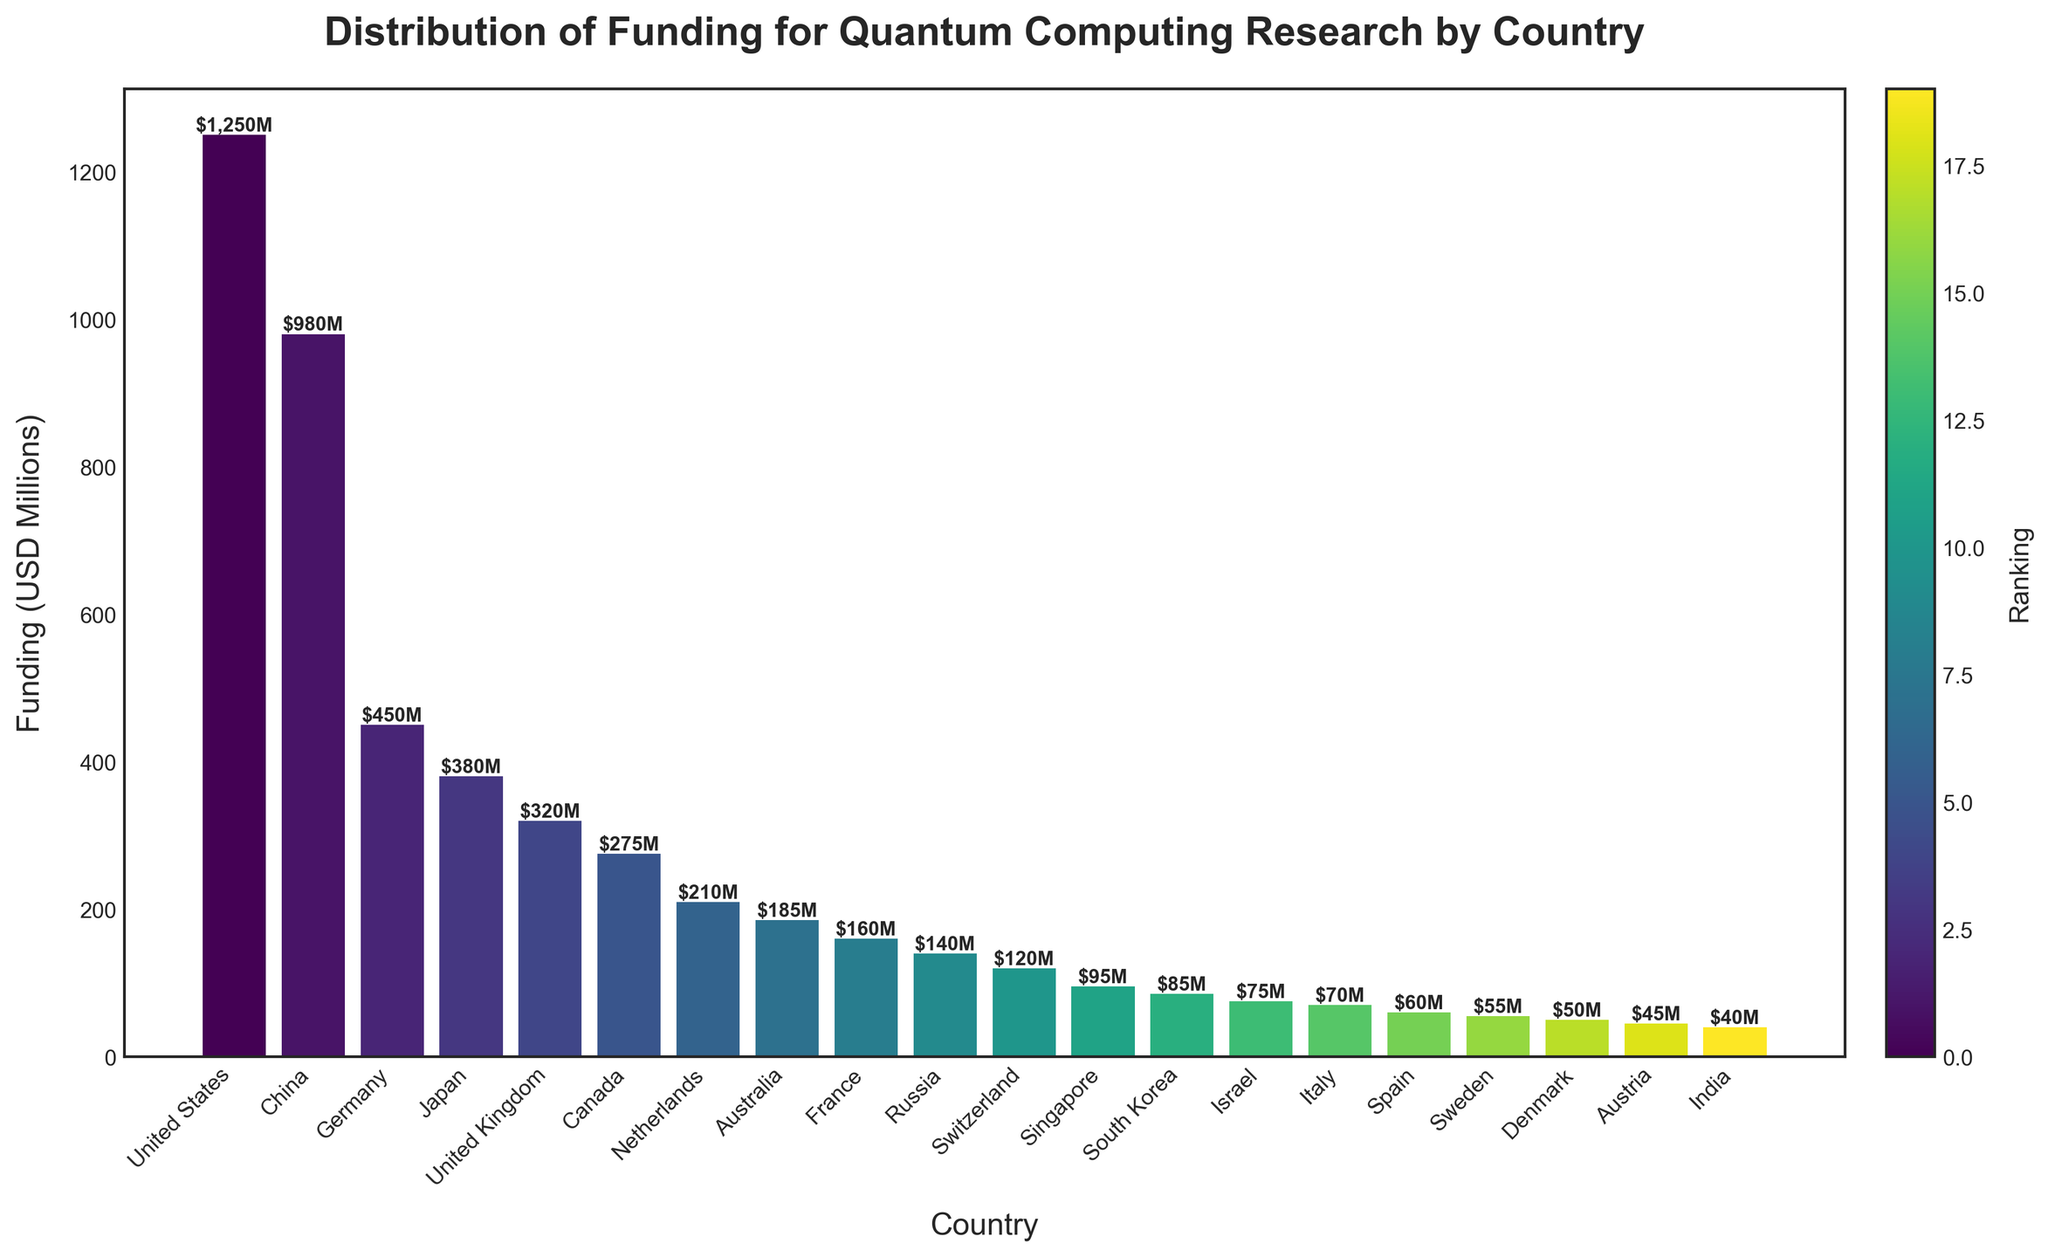What is the total funding for quantum computing research by the top three countries? The top three countries in terms of funding are the United States, China, and Germany. Adding their funding: $1,250M (US) + $980M (China) + $450M (Germany) = $2,680M
Answer: $2,680M Which country has the highest funding for quantum computing research? The bar representing the United States is the tallest among all the bars, indicating the highest funding.
Answer: United States What is the average funding for quantum computing among all the countries listed? To find the average, sum all the funding values and divide by the total number of countries. The total funding is $5,970M, and there are 20 countries. $5,970M / 20 = $298.5M
Answer: $298.5M Compare the funding between China and Japan. Which country has more funding and by how much? The funding for China is $980M, and for Japan, it is $380M. The difference is $980M - $380M = $600M.
Answer: China by $600M Which country ranks fourth in terms of funding for quantum computing research? After sorting the countries by funding, the fourth country is Japan with $380M in funding.
Answer: Japan What is the total combined funding for countries that have less than $100M each? The countries with less than $100M in funding are Singapore, South Korea, Israel, Italy, Spain, Sweden, Denmark, Austria, and India. Adding their funding: $95M + $85M + $75M + $70M + $60M + $55M + $50M + $45M + $40M = $575M
Answer: $575M How does the funding of the United Kingdom compare to Canada in quantum computing research? The funding for the United Kingdom is $320M, and for Canada, it is $275M. The difference is $320M - $275M = $45M
Answer: United Kingdom by $45M Which three countries have the lowest funding for quantum computing research? The three countries with the lowest funding are India, Austria, and Denmark with $40M, $45M, and $50M respectively.
Answer: India, Austria, Denmark By how much does the funding in France fall short of the funding in the Netherlands? The funding in France is $160M, and in the Netherlands, it is $210M. The difference is $210M - $160M = $50M
Answer: $50M What is the median funding amount among the countries listed? Median is the middle value when the numbers are sorted. There are 20 countries, so the median is the average of the 10th and 11th values. Sorting the values gives the 10th as $140M (Russia) and the 11th as $120M (Switzerland). The median is ($140M + $120M) / 2 = $130M
Answer: $130M 